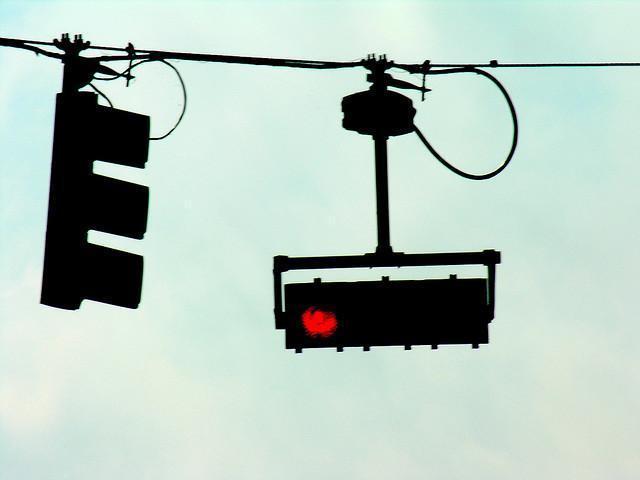How many colored lights are on the signal to the left?
Give a very brief answer. 3. How many traffic lights can be seen?
Give a very brief answer. 2. 